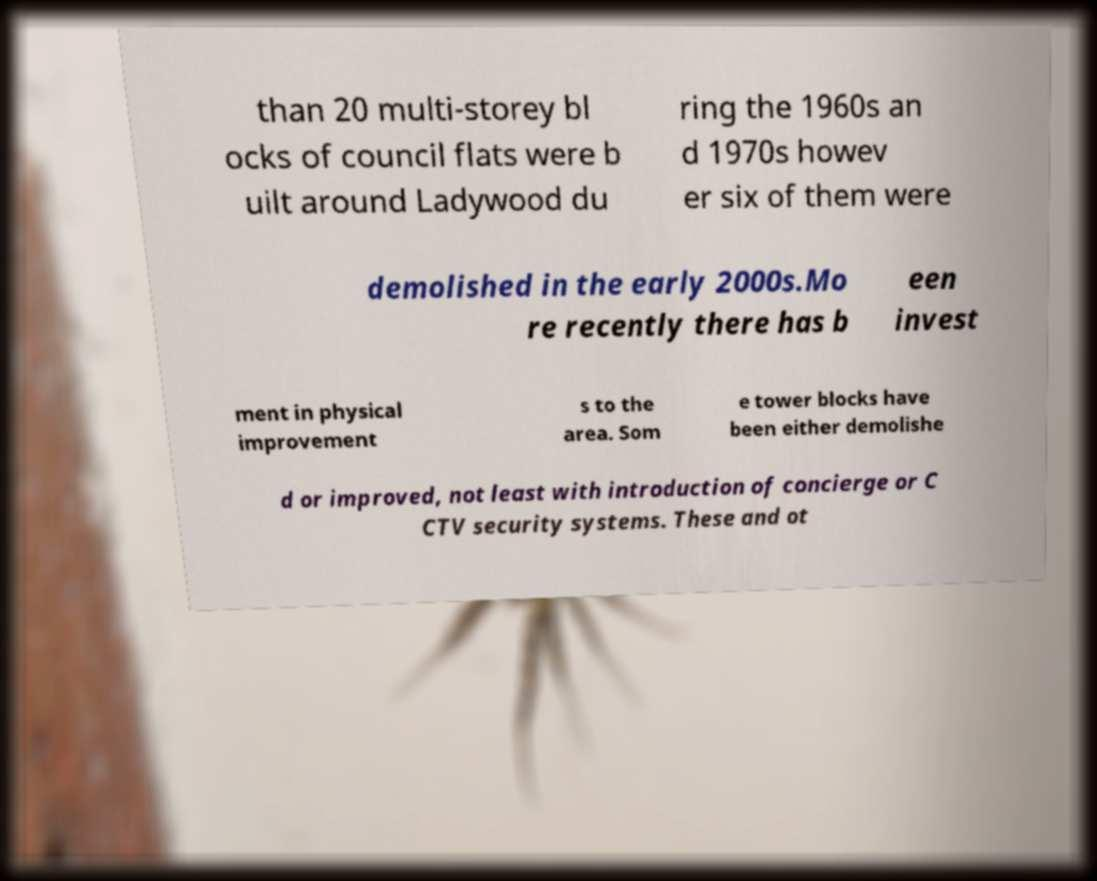Please identify and transcribe the text found in this image. than 20 multi-storey bl ocks of council flats were b uilt around Ladywood du ring the 1960s an d 1970s howev er six of them were demolished in the early 2000s.Mo re recently there has b een invest ment in physical improvement s to the area. Som e tower blocks have been either demolishe d or improved, not least with introduction of concierge or C CTV security systems. These and ot 